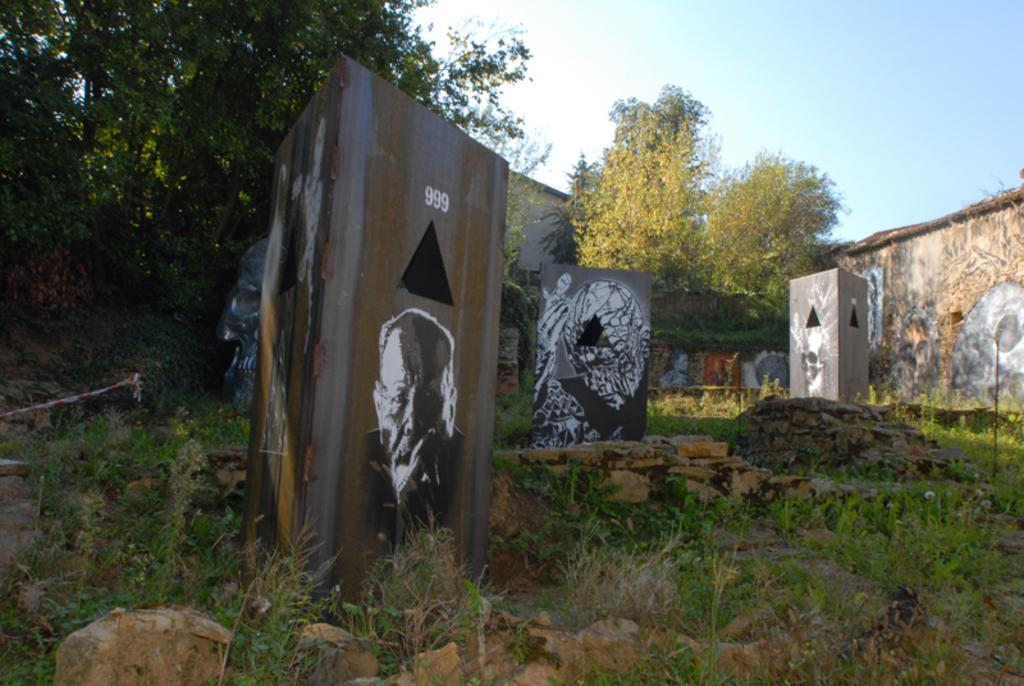What type of artwork can be seen in the image? There is graffiti in the image. What type of natural environment is visible in the image? There is grass and trees visible in the image. What type of structures are present in the image? There are walls in the image. What is visible in the background of the image? The sky is visible in the background of the image. What type of slope can be seen in the image? There is no slope present in the image. Who is the representative in the image? There is no representative present in the image. 